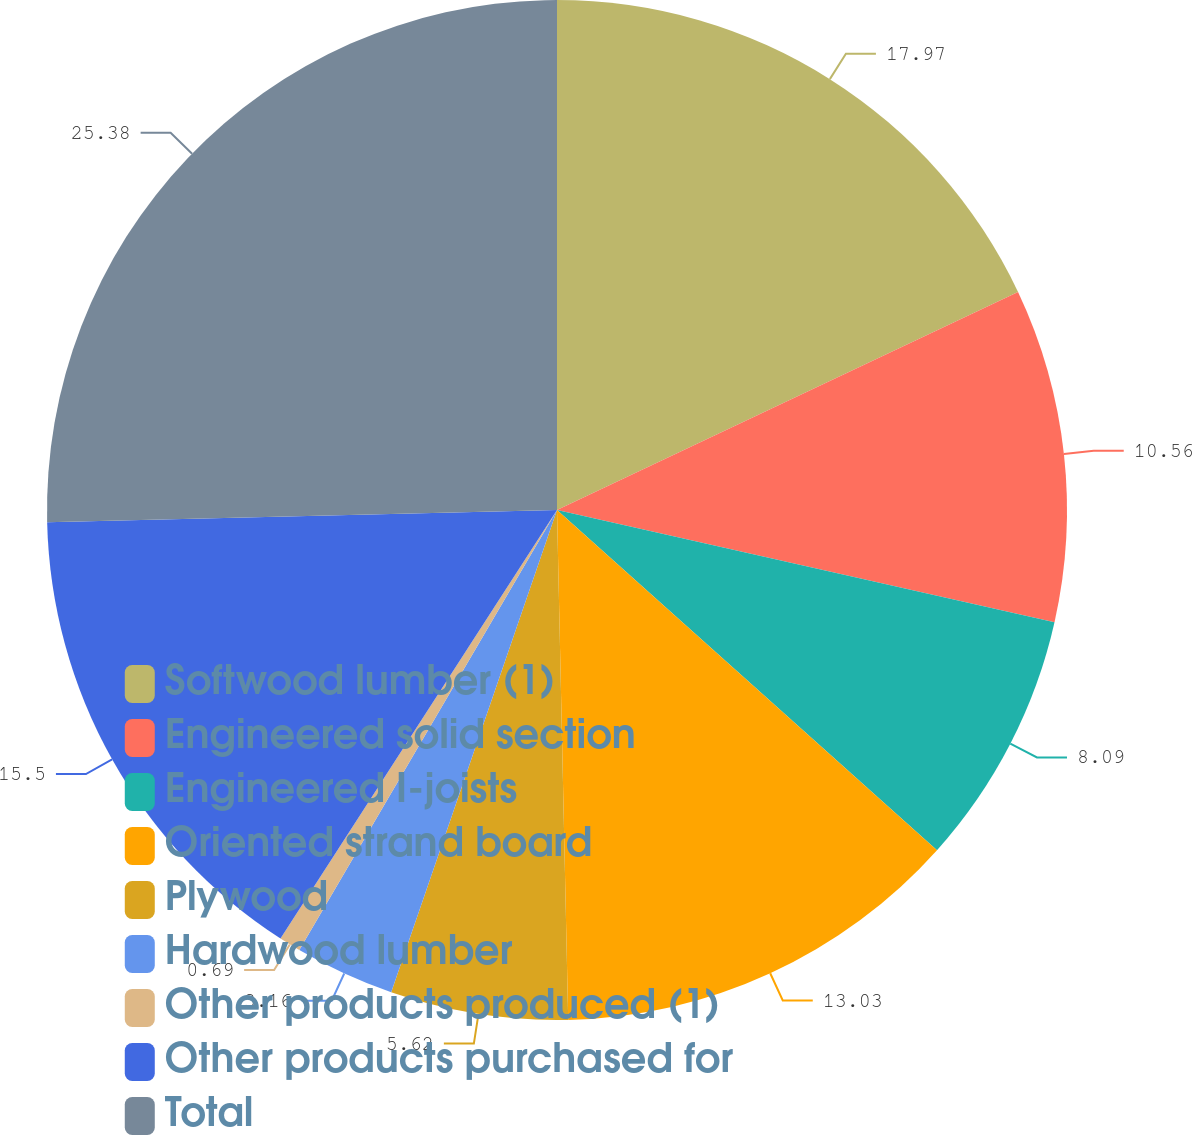Convert chart to OTSL. <chart><loc_0><loc_0><loc_500><loc_500><pie_chart><fcel>Softwood lumber (1)<fcel>Engineered solid section<fcel>Engineered I-joists<fcel>Oriented strand board<fcel>Plywood<fcel>Hardwood lumber<fcel>Other products produced (1)<fcel>Other products purchased for<fcel>Total<nl><fcel>17.97%<fcel>10.56%<fcel>8.09%<fcel>13.03%<fcel>5.62%<fcel>3.16%<fcel>0.69%<fcel>15.5%<fcel>25.38%<nl></chart> 